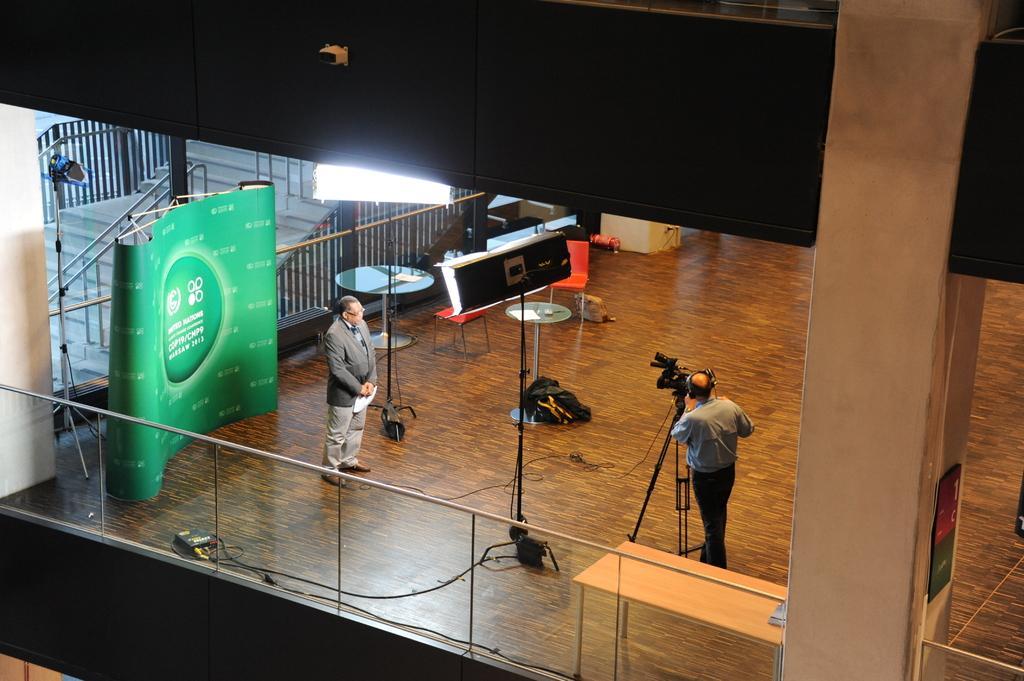Please provide a concise description of this image. In this image there is a man standing on the wooden floor. Behind him there is a banner. On the right side there is a man who is taking the video with the camera which is in front of him. There are two lights which are focusing on the man who is standing in front of the banner. It looks like it is a video shoot. 